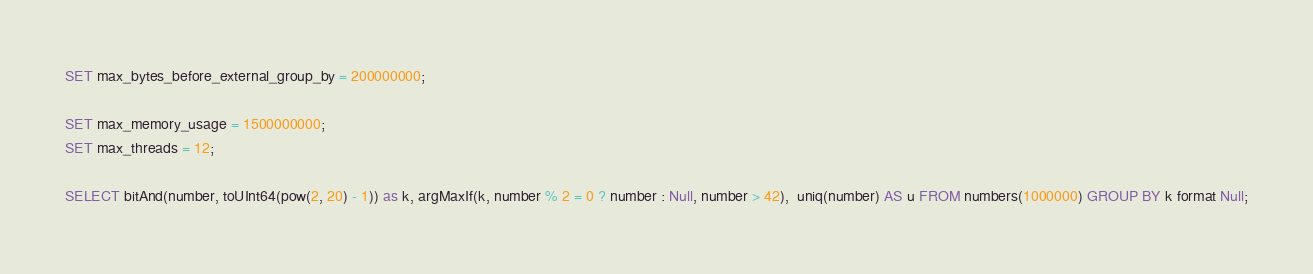<code> <loc_0><loc_0><loc_500><loc_500><_SQL_>SET max_bytes_before_external_group_by = 200000000;

SET max_memory_usage = 1500000000;
SET max_threads = 12;

SELECT bitAnd(number, toUInt64(pow(2, 20) - 1)) as k, argMaxIf(k, number % 2 = 0 ? number : Null, number > 42),  uniq(number) AS u FROM numbers(1000000) GROUP BY k format Null;

</code> 